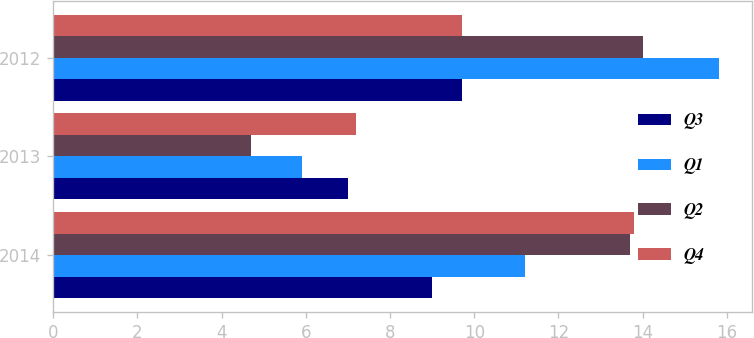Convert chart to OTSL. <chart><loc_0><loc_0><loc_500><loc_500><stacked_bar_chart><ecel><fcel>2014<fcel>2013<fcel>2012<nl><fcel>Q3<fcel>9<fcel>7<fcel>9.7<nl><fcel>Q1<fcel>11.2<fcel>5.9<fcel>15.8<nl><fcel>Q2<fcel>13.7<fcel>4.7<fcel>14<nl><fcel>Q4<fcel>13.8<fcel>7.2<fcel>9.7<nl></chart> 